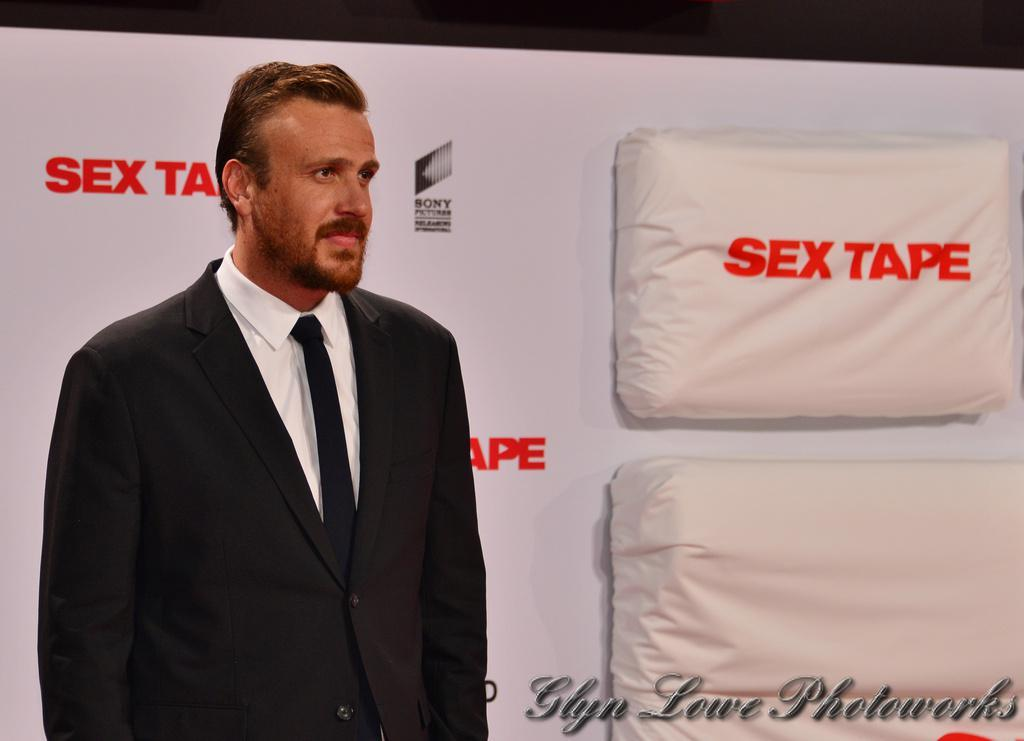Who is present in the image? There is a man in the image. What is the man wearing? The man is wearing a black suit, a white shirt, and a tie. What can be seen in the background of the image? There is a banner in the background of the image. What is the banner made of? The banner is made of cloth material. What is written on the banner? There are texts at the bottom of the banner. What type of quince is being served at the event in the image? There is no quince or event present in the image; it only features a man and a banner. What error can be seen in the car's design in the image? There is no car present in the image, so it is not possible to identify any design errors. 